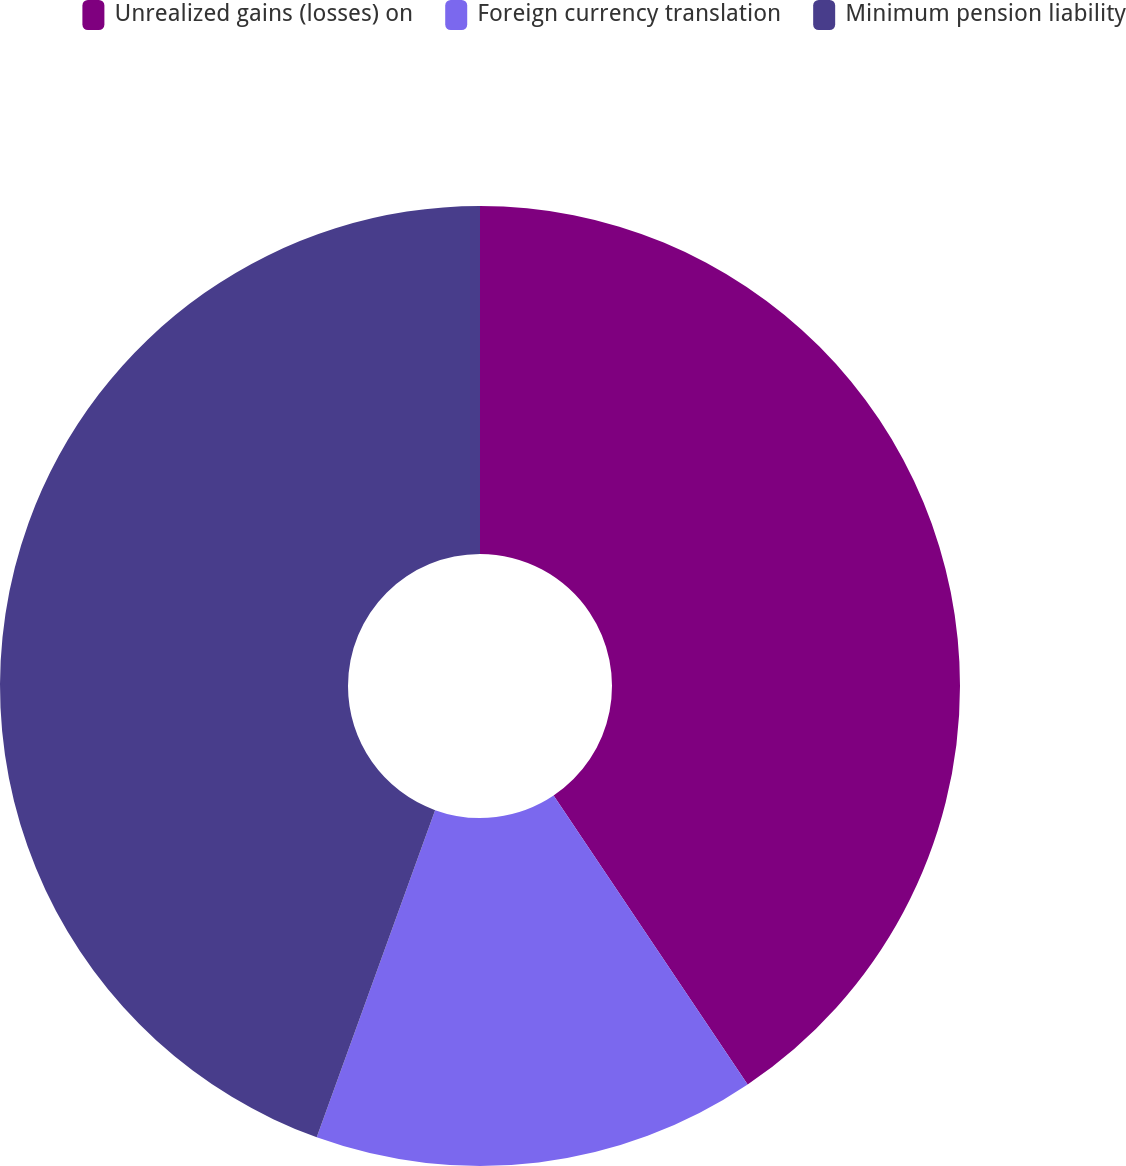<chart> <loc_0><loc_0><loc_500><loc_500><pie_chart><fcel>Unrealized gains (losses) on<fcel>Foreign currency translation<fcel>Minimum pension liability<nl><fcel>40.59%<fcel>14.94%<fcel>44.48%<nl></chart> 